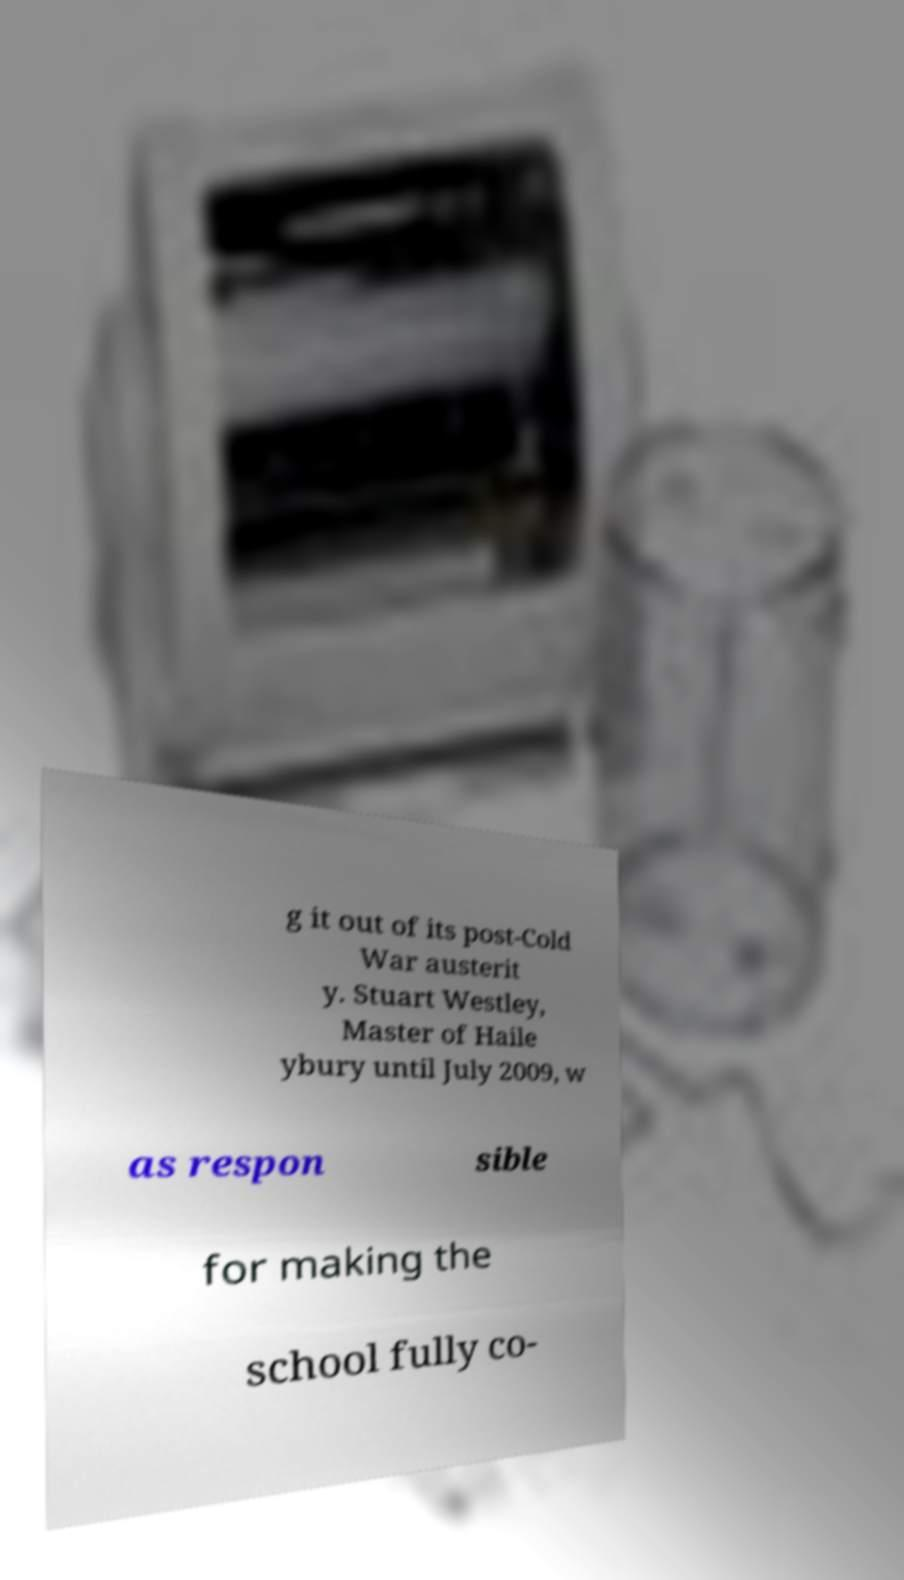Please identify and transcribe the text found in this image. g it out of its post-Cold War austerit y. Stuart Westley, Master of Haile ybury until July 2009, w as respon sible for making the school fully co- 